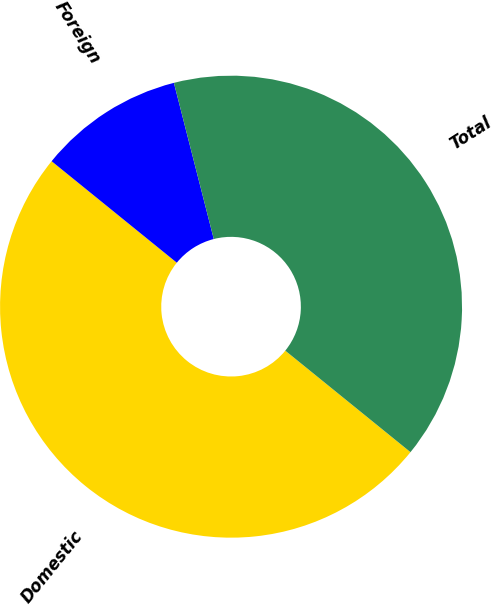Convert chart. <chart><loc_0><loc_0><loc_500><loc_500><pie_chart><fcel>Domestic<fcel>Foreign<fcel>Total<nl><fcel>50.0%<fcel>10.18%<fcel>39.82%<nl></chart> 